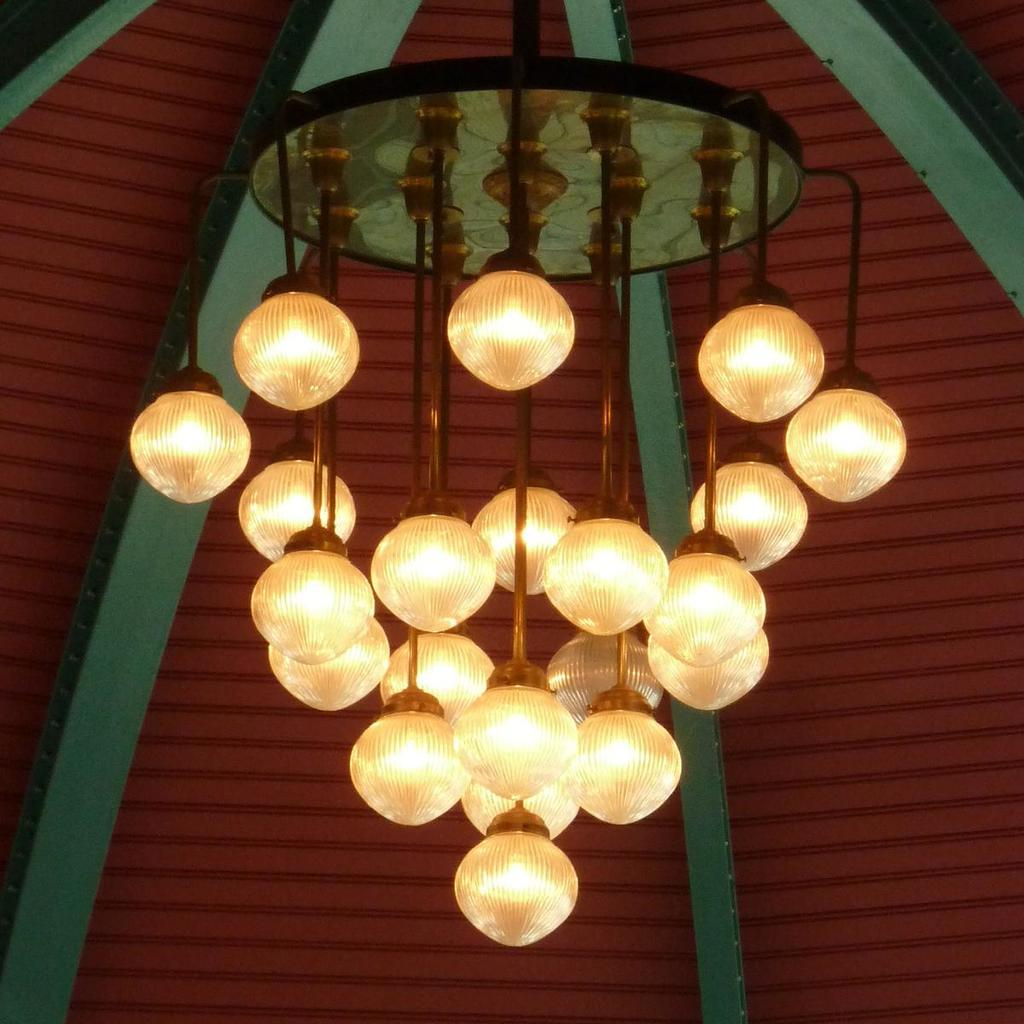What is hanging from the ceiling in the image? There are lights attached to the ceiling in the image. What color is the ceiling in the image? The ceiling in the backdrop is maroon. What type of frame is present in the image? There is a green frame in the frame in the backdrop. Can you tell me how many icicles are hanging from the green frame in the image? There are no icicles present in the image; it features lights attached to the ceiling and a green frame in the backdrop. What type of dog can be seen playing with the lights in the image? There is no dog present in the image; it only shows lights attached to the ceiling and a green frame in the backdrop. 